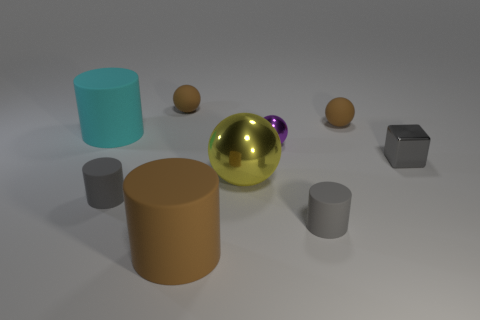Subtract 1 cylinders. How many cylinders are left? 3 Subtract all cylinders. How many objects are left? 5 Subtract 0 cyan cubes. How many objects are left? 9 Subtract all big cyan matte objects. Subtract all large yellow things. How many objects are left? 7 Add 7 brown rubber balls. How many brown rubber balls are left? 9 Add 7 tiny brown objects. How many tiny brown objects exist? 9 